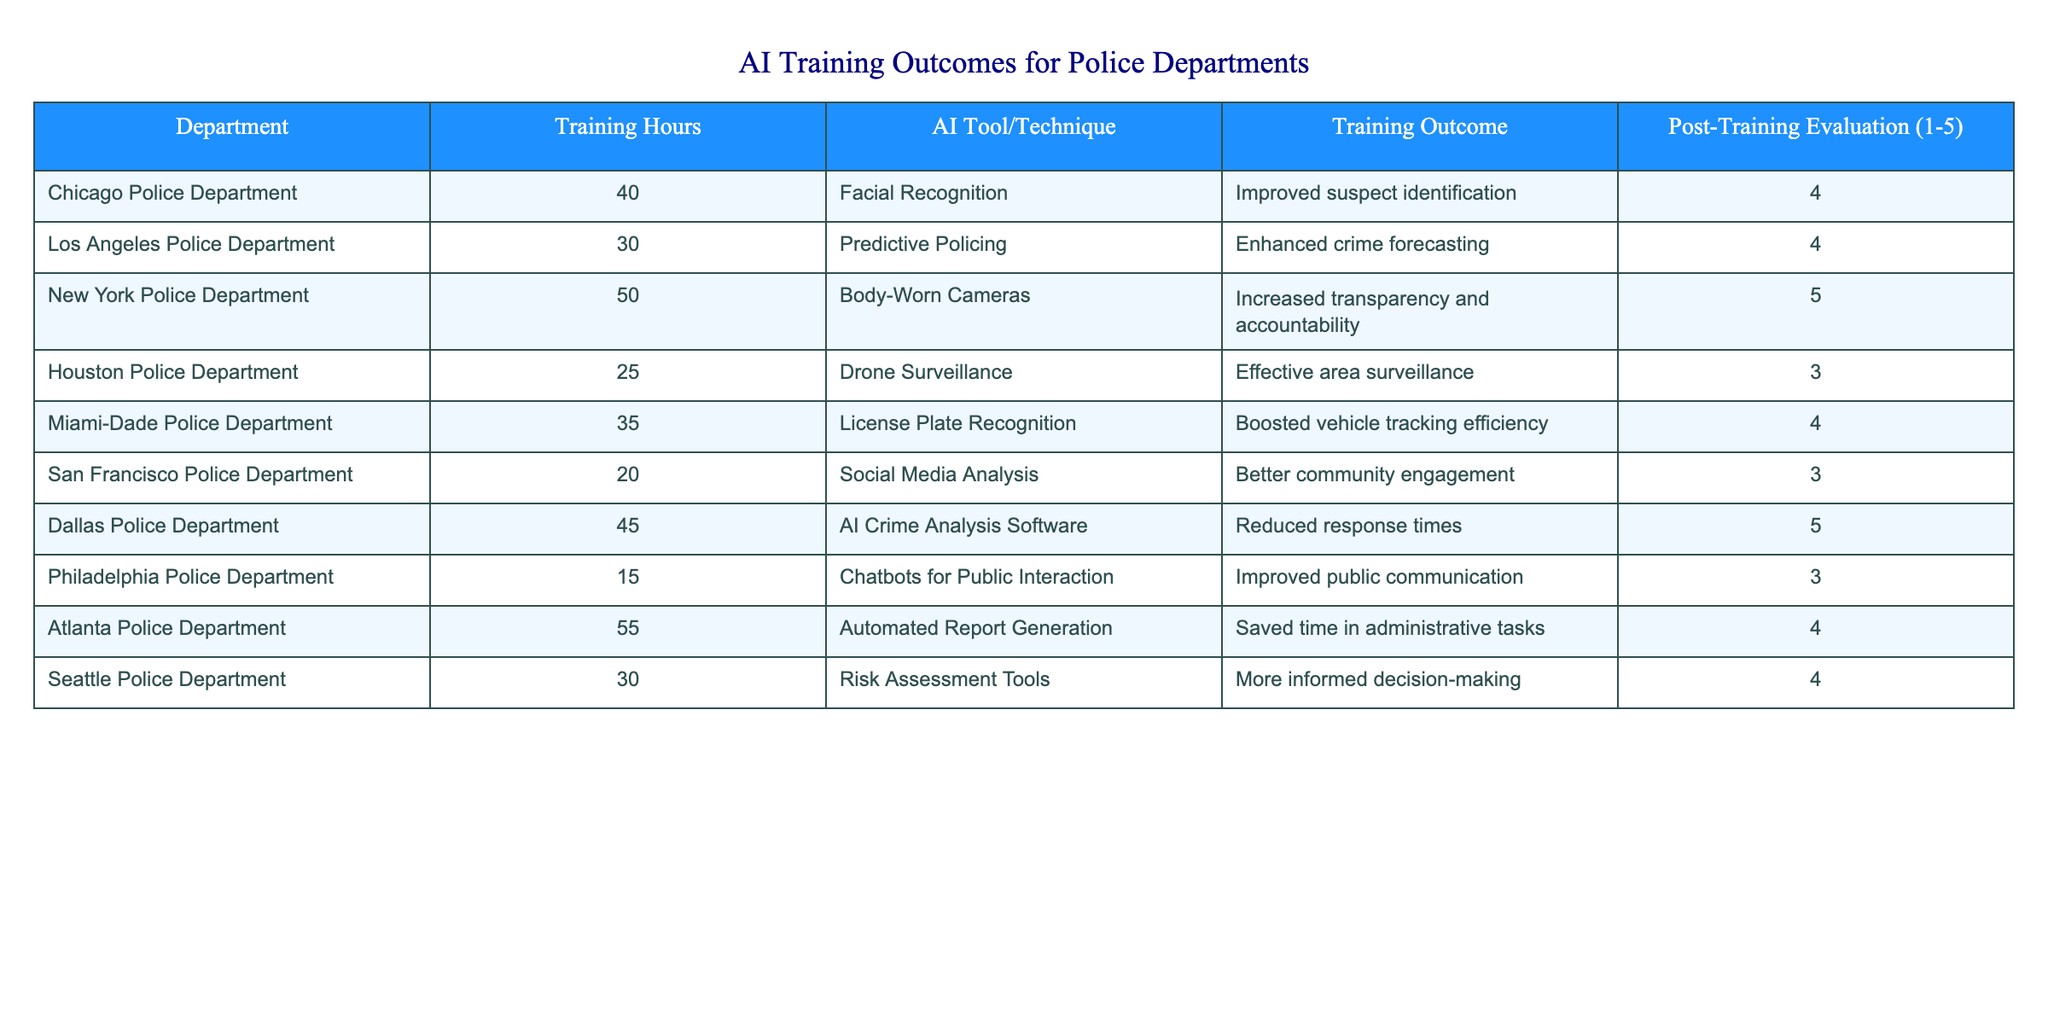What is the highest training outcome rating achieved? The table lists the post-training evaluation ratings, and the highest value is 5, which can be found in the rows for the New York Police Department and the Dallas Police Department.
Answer: 5 Which department received the least amount of training hours? By examining the training hours column, the department with the least amount of training hours is the Philadelphia Police Department, which received 15 hours of training.
Answer: Philadelphia Police Department What is the average training hours across all departments? To find the average, sum the training hours: (40 + 30 + 50 + 25 + 35 + 20 + 45 + 15 + 55 + 30) =  400. There are 10 departments, so the average is 400 / 10 = 40.
Answer: 40 Did the Houston Police Department receive a training outcome rating of at least 4? The Houston Police Department received a training outcome rating of 3, which is less than 4.
Answer: No Which AI tool/technique was used by a department with an outcome score of 5, and how many training hours did that department receive? The Dallas Police Department used AI Crime Analysis Software with a training outcome score of 5 and received 45 training hours.
Answer: AI Crime Analysis Software, 45 hours How many departments reported an improved outcome rating of 4 or above? The departments with an outcome rating of 4 or above are as follows: New York Police Department, Chicago Police Department, Los Angeles Police Department, Miami-Dade Police Department, Dallas Police Department, Atlanta Police Department, and Seattle Police Department. This totals seven departments.
Answer: 7 Calculate the difference in training hours between the department with the most training hours and the department with the least. The New York Police Department had the most training hours at 50, while the Philadelphia Police Department had the least at 15. The difference is 50 - 15 = 35 hours.
Answer: 35 Is there any department that used "Social Media Analysis" as an AI tool and received a training outcome of 4 or higher? The San Francisco Police Department used "Social Media Analysis" and received a training outcome of 3, which is not 4 or higher. Therefore, there are no departments that meet this criterion.
Answer: No Which two departments had the same training outcome rating and what was it? The Houston Police Department and the San Francisco Police Department both had a training outcome rating of 3.
Answer: Training outcome is 3, Houston and San Francisco Police Departments 